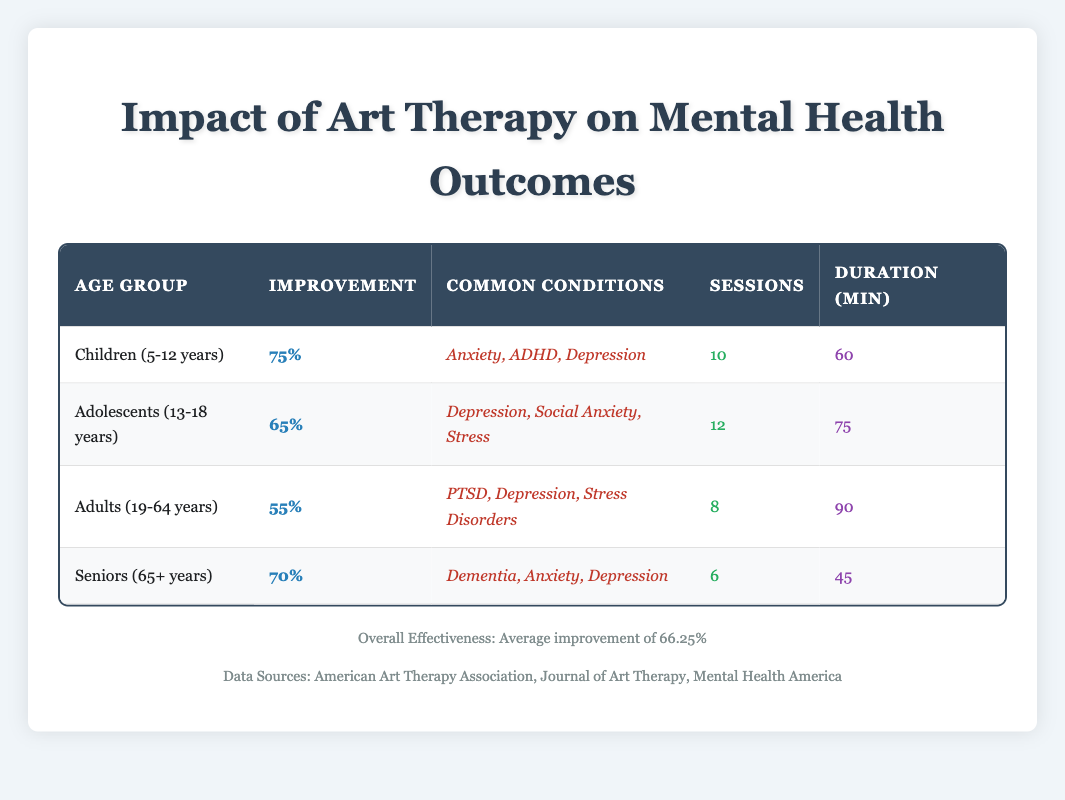What is the percentage improvement in mental health outcomes for Children aged 5-12 years? The table lists the percentage improvement for the Children age group as 75%.
Answer: 75% How many therapy sessions are recommended for Adolescents aged 13-18 years? According to the table, adolescents are recommended to attend 12 therapy sessions.
Answer: 12 What is the average percentage improvement across all age demographics found in the study? The average percentage improvement is calculated from the values given in the table for each age group: (75 + 65 + 55 + 70) / 4 = 66.25%.
Answer: 66.25% Is "Dementia" among the common conditions treated with art therapy for Seniors aged 65 years and older? The table indicates that dementia is listed as one of the common conditions treated for the Seniors age group, hence the answer is yes.
Answer: Yes Which age group has the lowest percentage improvement in mental health outcomes? The table shows Adults aged 19-64 years have the lowest percentage improvement at 55%, compared to the other age groups.
Answer: Adults (19-64 years) What is the total number of therapy sessions recommended for all age groups combined? The total number of therapy sessions can be calculated by summing the sessions from all age groups: 10 + 12 + 8 + 6 = 36 sessions.
Answer: 36 What average session duration in minutes is noted for Children aged 5-12 years? According to the table, the average session duration for Children is 60 minutes.
Answer: 60 minutes For which age group is the percentage improvement the highest, and what is that percentage? The table shows that the highest percentage improvement is for Children (5-12 years) at 75%.
Answer: Children (5-12 years), 75% How does the average session duration correlate with the percentage improvement across the age demographics? By reviewing the data, we see that as session durations decrease, there is a tendency for the percentage improvement to also decrease (Children: 60 min, 75%; Adolescents: 75 min, 65%; Adults: 90 min, 55%; Seniors: 45 min, 70%).
Answer: There is a tendency for longer sessions to correlate with lower improvement percentages 